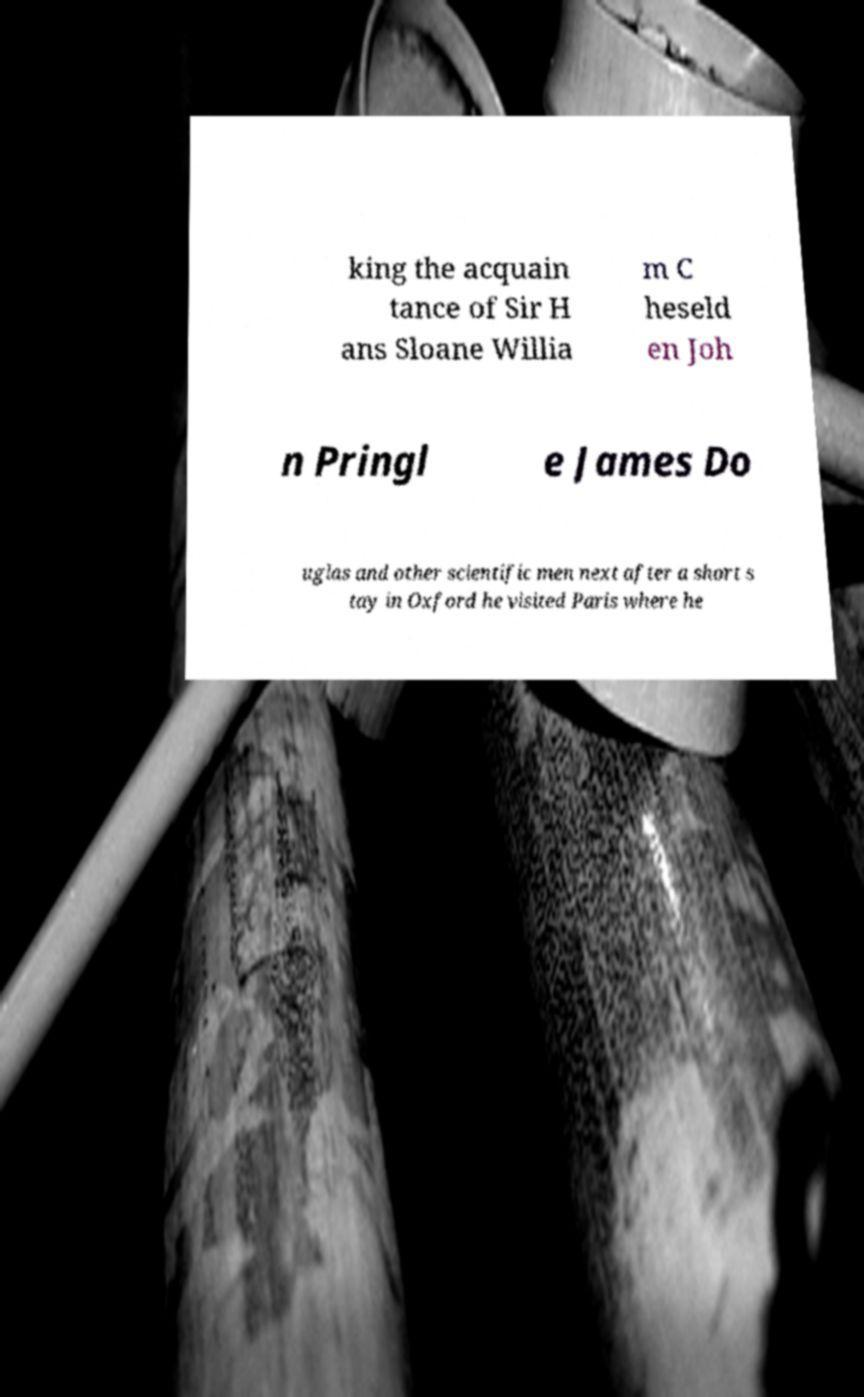Please identify and transcribe the text found in this image. king the acquain tance of Sir H ans Sloane Willia m C heseld en Joh n Pringl e James Do uglas and other scientific men next after a short s tay in Oxford he visited Paris where he 